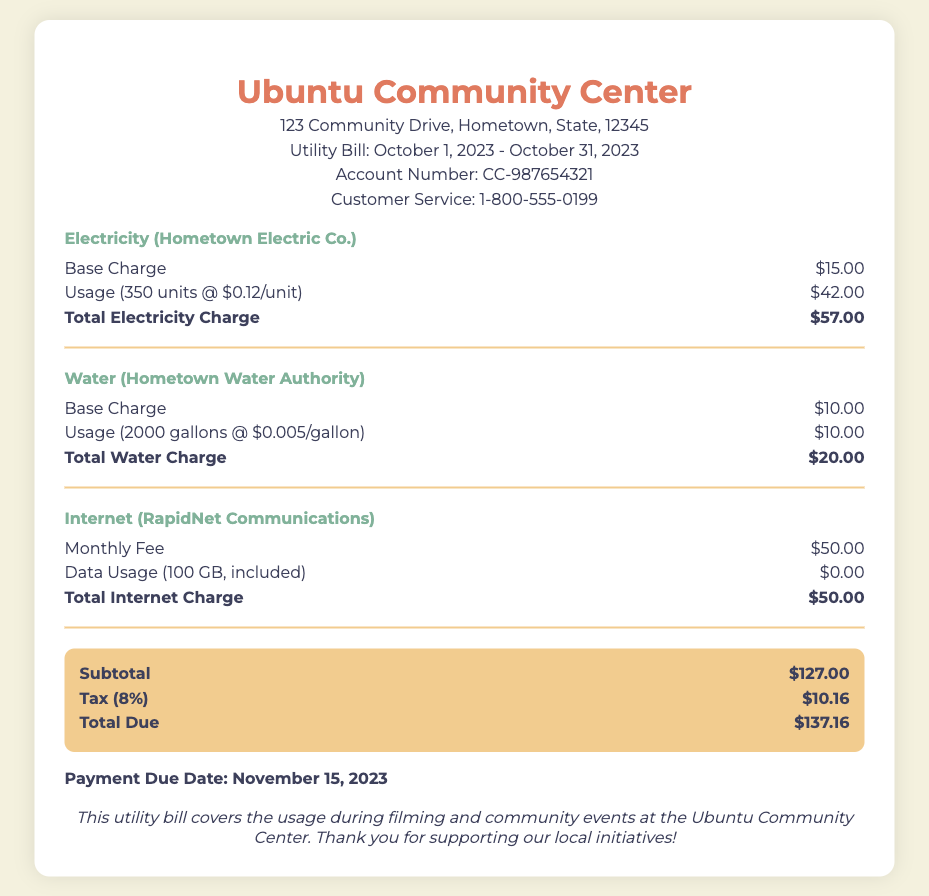What is the account number? The account number is listed in the document as CC-987654321.
Answer: CC-987654321 What is the total electricity charge? The total electricity charge is prominently displayed after the charge items for electricity, which is $57.00.
Answer: $57.00 What is the base charge for water? The document specifies that the base charge for water is $10.00.
Answer: $10.00 What is the subtotal for all charges? The subtotal is calculated as the sum of all charges before tax, which is $127.00.
Answer: $127.00 What is the tax amount? The tax amount is listed as 8% of the subtotal, which equals $10.16.
Answer: $10.16 What is the payment due date? The payment due date is indicated in the document as November 15, 2023.
Answer: November 15, 2023 What is included in the internet charge? The internet charge document includes a monthly fee along with data usage that is provided at no additional cost.
Answer: $50.00 What is the total due amount? The total due is clearly stated as $137.16, which includes all charges plus tax.
Answer: $137.16 What organization provides water services? The document identifies the water services provider as Hometown Water Authority.
Answer: Hometown Water Authority 